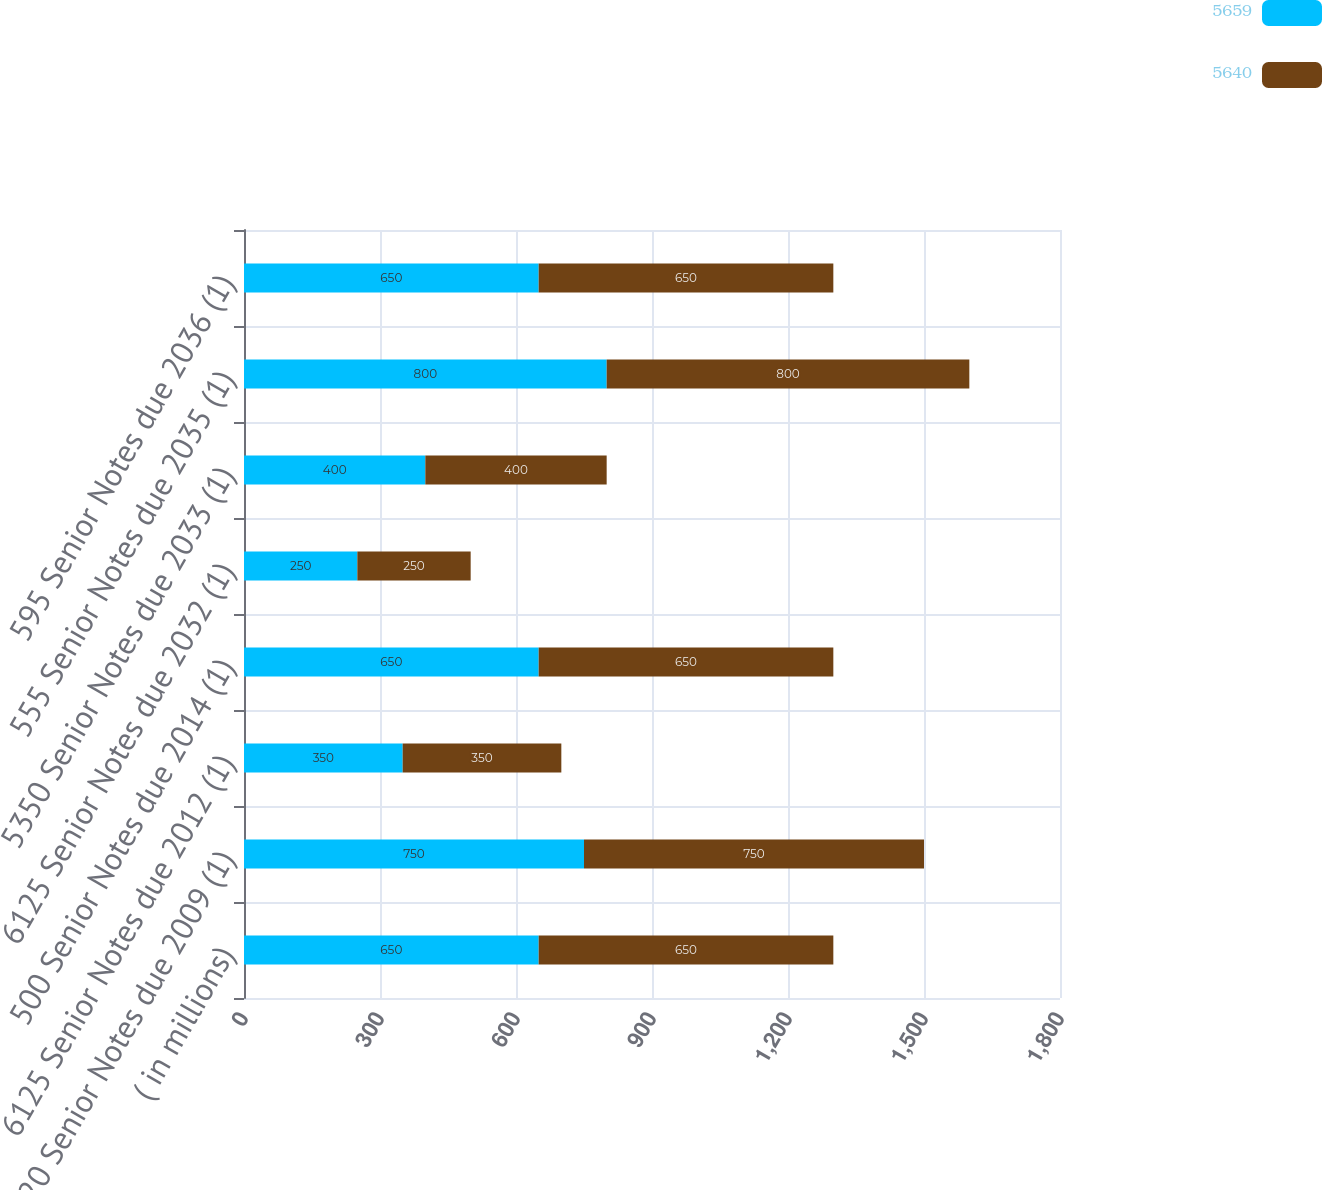Convert chart. <chart><loc_0><loc_0><loc_500><loc_500><stacked_bar_chart><ecel><fcel>( in millions)<fcel>720 Senior Notes due 2009 (1)<fcel>6125 Senior Notes due 2012 (1)<fcel>500 Senior Notes due 2014 (1)<fcel>6125 Senior Notes due 2032 (1)<fcel>5350 Senior Notes due 2033 (1)<fcel>555 Senior Notes due 2035 (1)<fcel>595 Senior Notes due 2036 (1)<nl><fcel>5659<fcel>650<fcel>750<fcel>350<fcel>650<fcel>250<fcel>400<fcel>800<fcel>650<nl><fcel>5640<fcel>650<fcel>750<fcel>350<fcel>650<fcel>250<fcel>400<fcel>800<fcel>650<nl></chart> 